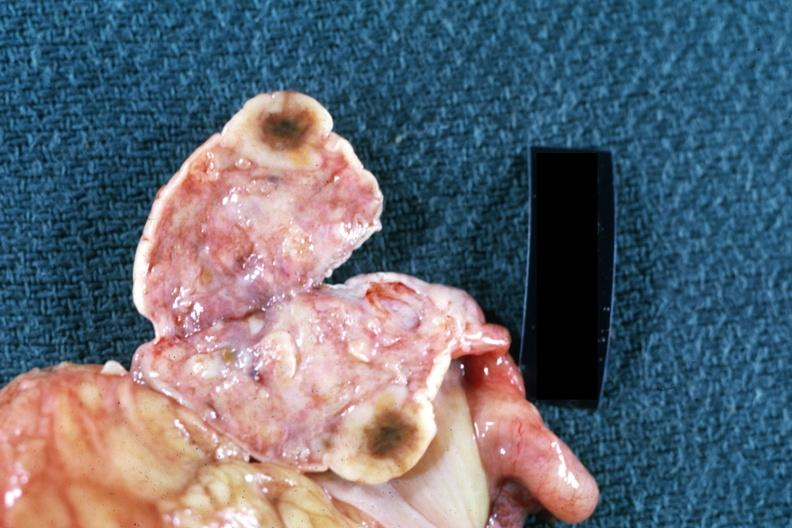does mesothelioma show close-up single lesion well shown breast primary?
Answer the question using a single word or phrase. No 